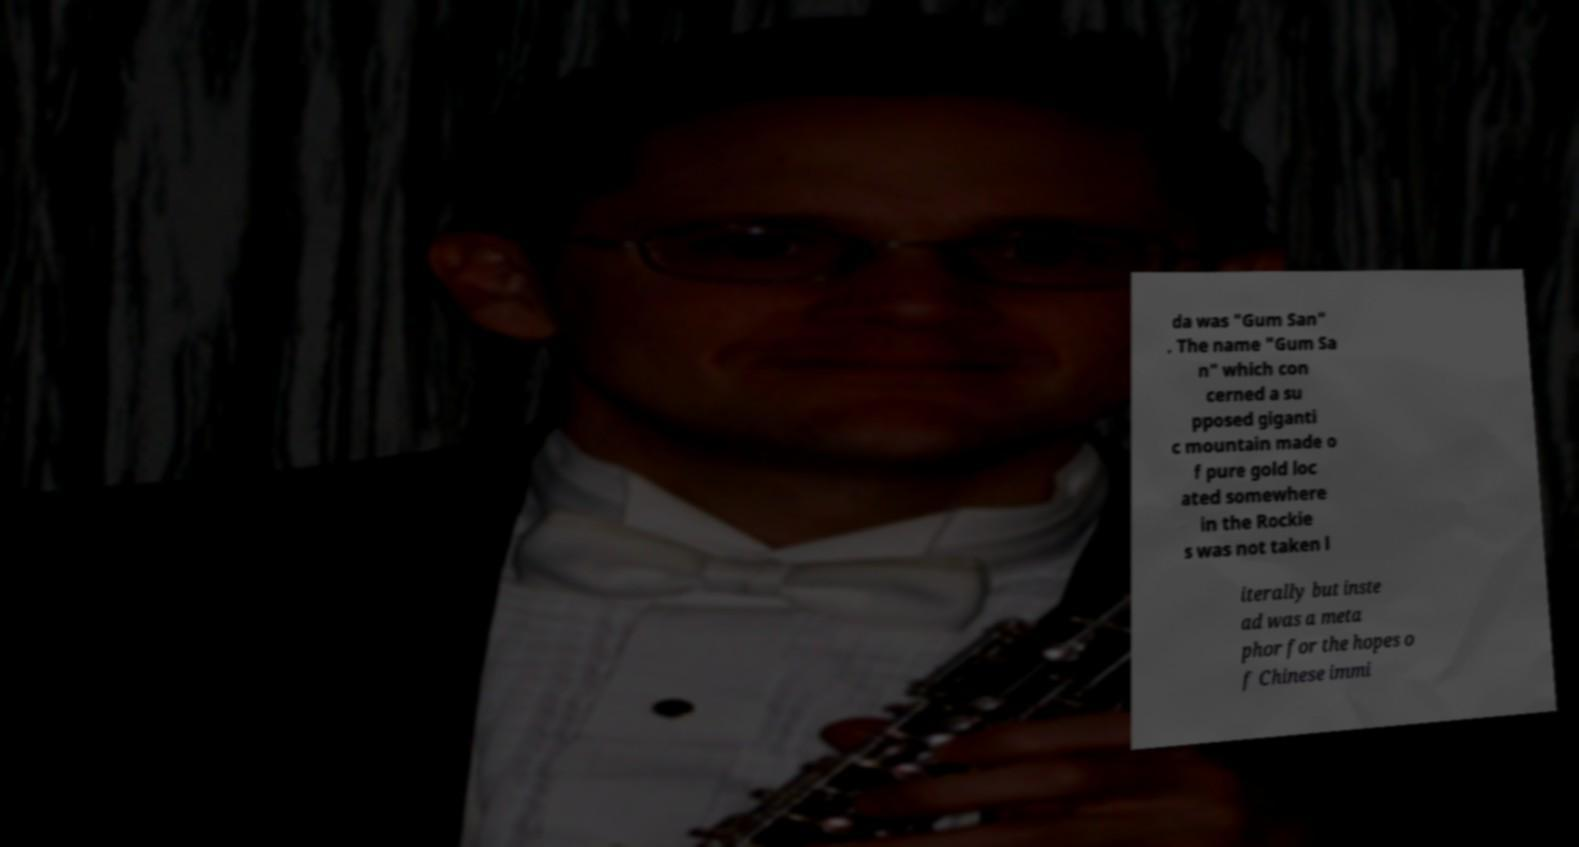I need the written content from this picture converted into text. Can you do that? da was "Gum San" . The name "Gum Sa n" which con cerned a su pposed giganti c mountain made o f pure gold loc ated somewhere in the Rockie s was not taken l iterally but inste ad was a meta phor for the hopes o f Chinese immi 